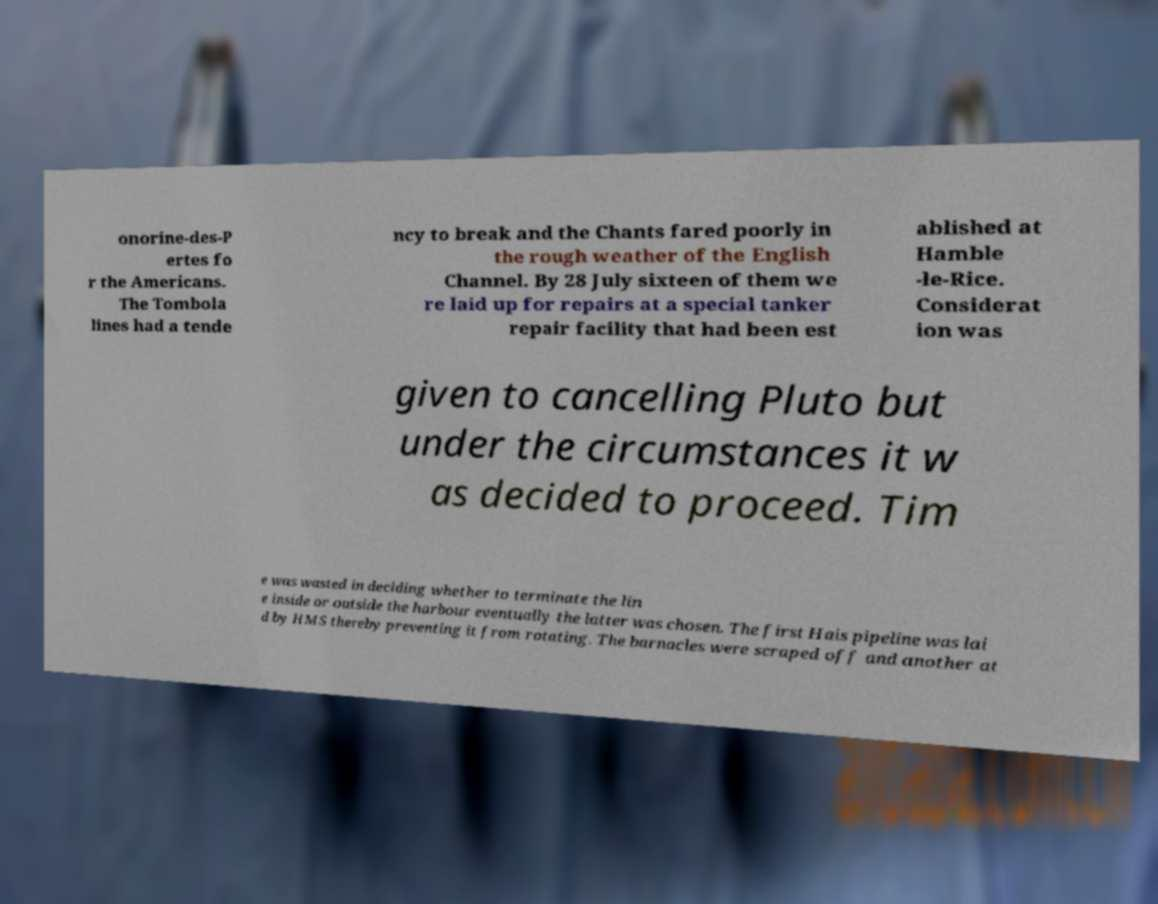Please read and relay the text visible in this image. What does it say? onorine-des-P ertes fo r the Americans. The Tombola lines had a tende ncy to break and the Chants fared poorly in the rough weather of the English Channel. By 28 July sixteen of them we re laid up for repairs at a special tanker repair facility that had been est ablished at Hamble -le-Rice. Considerat ion was given to cancelling Pluto but under the circumstances it w as decided to proceed. Tim e was wasted in deciding whether to terminate the lin e inside or outside the harbour eventually the latter was chosen. The first Hais pipeline was lai d by HMS thereby preventing it from rotating. The barnacles were scraped off and another at 